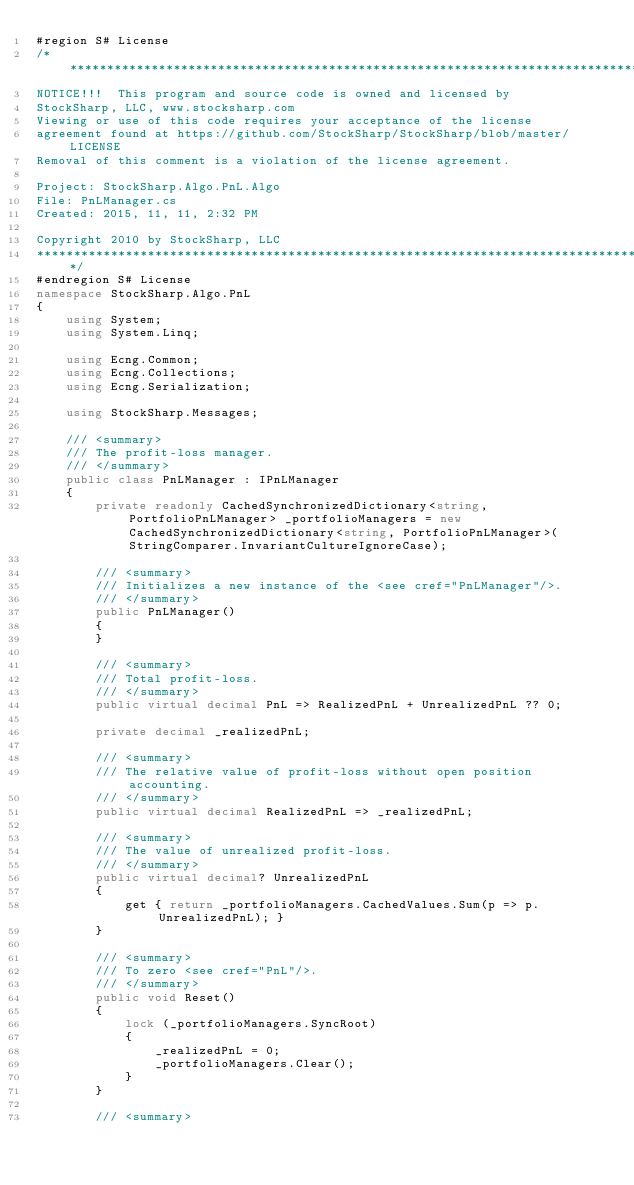<code> <loc_0><loc_0><loc_500><loc_500><_C#_>#region S# License
/******************************************************************************************
NOTICE!!!  This program and source code is owned and licensed by
StockSharp, LLC, www.stocksharp.com
Viewing or use of this code requires your acceptance of the license
agreement found at https://github.com/StockSharp/StockSharp/blob/master/LICENSE
Removal of this comment is a violation of the license agreement.

Project: StockSharp.Algo.PnL.Algo
File: PnLManager.cs
Created: 2015, 11, 11, 2:32 PM

Copyright 2010 by StockSharp, LLC
*******************************************************************************************/
#endregion S# License
namespace StockSharp.Algo.PnL
{
	using System;
	using System.Linq;

	using Ecng.Common;
	using Ecng.Collections;
	using Ecng.Serialization;

	using StockSharp.Messages;

	/// <summary>
	/// The profit-loss manager.
	/// </summary>
	public class PnLManager : IPnLManager
	{
		private readonly CachedSynchronizedDictionary<string, PortfolioPnLManager> _portfolioManagers = new CachedSynchronizedDictionary<string, PortfolioPnLManager>(StringComparer.InvariantCultureIgnoreCase);

		/// <summary>
		/// Initializes a new instance of the <see cref="PnLManager"/>.
		/// </summary>
		public PnLManager()
		{
		}

		/// <summary>
		/// Total profit-loss.
		/// </summary>
		public virtual decimal PnL => RealizedPnL + UnrealizedPnL ?? 0;

		private decimal _realizedPnL;

		/// <summary>
		/// The relative value of profit-loss without open position accounting.
		/// </summary>
		public virtual decimal RealizedPnL => _realizedPnL;

		/// <summary>
		/// The value of unrealized profit-loss.
		/// </summary>
		public virtual decimal? UnrealizedPnL
		{
			get { return _portfolioManagers.CachedValues.Sum(p => p.UnrealizedPnL); }
		}

		/// <summary>
		/// To zero <see cref="PnL"/>.
		/// </summary>
		public void Reset()
		{
			lock (_portfolioManagers.SyncRoot)
			{
				_realizedPnL = 0;
				_portfolioManagers.Clear();	
			}
		}

		/// <summary></code> 